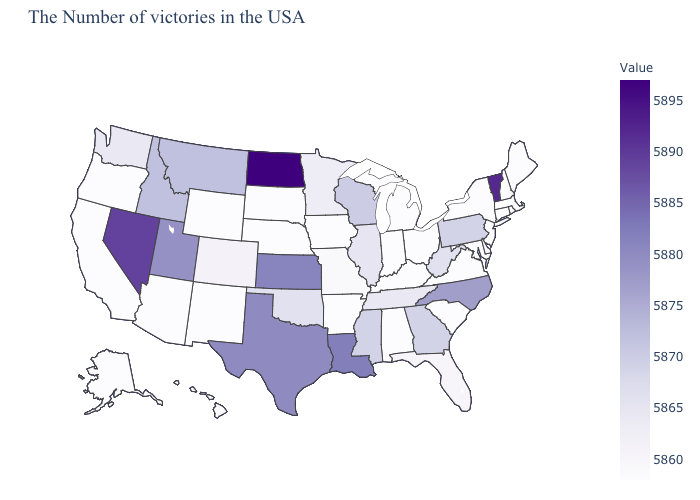Does Michigan have the highest value in the USA?
Give a very brief answer. No. Among the states that border Michigan , which have the highest value?
Give a very brief answer. Wisconsin. Which states hav the highest value in the Northeast?
Short answer required. Vermont. Which states have the lowest value in the West?
Short answer required. Wyoming, New Mexico, Arizona, California, Oregon, Alaska, Hawaii. Does Nevada have the highest value in the West?
Write a very short answer. Yes. Does North Dakota have the highest value in the MidWest?
Concise answer only. Yes. 